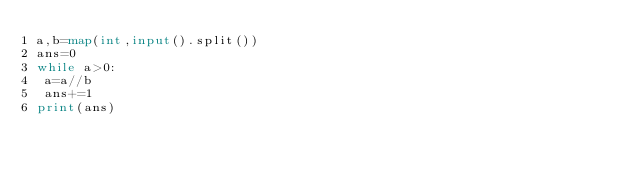Convert code to text. <code><loc_0><loc_0><loc_500><loc_500><_Python_>a,b=map(int,input().split())
ans=0
while a>0:
 a=a//b
 ans+=1
print(ans)</code> 